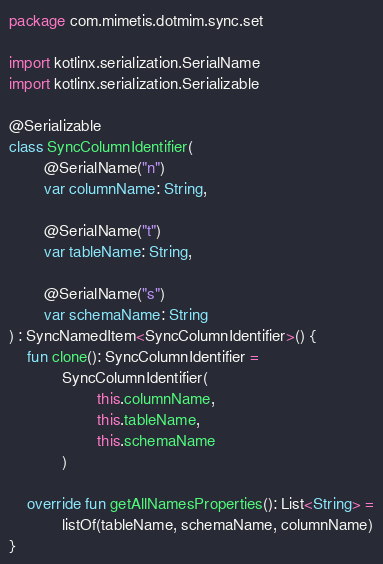<code> <loc_0><loc_0><loc_500><loc_500><_Kotlin_>package com.mimetis.dotmim.sync.set

import kotlinx.serialization.SerialName
import kotlinx.serialization.Serializable

@Serializable
class SyncColumnIdentifier(
        @SerialName("n")
        var columnName: String,

        @SerialName("t")
        var tableName: String,

        @SerialName("s")
        var schemaName: String
) : SyncNamedItem<SyncColumnIdentifier>() {
    fun clone(): SyncColumnIdentifier =
            SyncColumnIdentifier(
                    this.columnName,
                    this.tableName,
                    this.schemaName
            )

    override fun getAllNamesProperties(): List<String> =
            listOf(tableName, schemaName, columnName)
}
</code> 